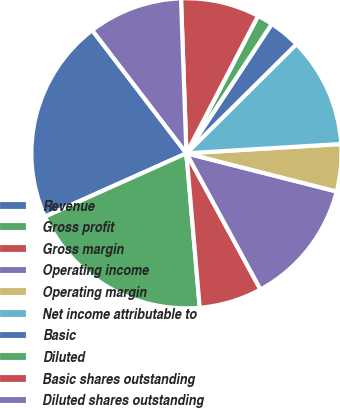<chart> <loc_0><loc_0><loc_500><loc_500><pie_chart><fcel>Revenue<fcel>Gross profit<fcel>Gross margin<fcel>Operating income<fcel>Operating margin<fcel>Net income attributable to<fcel>Basic<fcel>Diluted<fcel>Basic shares outstanding<fcel>Diluted shares outstanding<nl><fcel>21.31%<fcel>19.67%<fcel>6.56%<fcel>13.11%<fcel>4.92%<fcel>11.48%<fcel>3.28%<fcel>1.64%<fcel>8.2%<fcel>9.84%<nl></chart> 